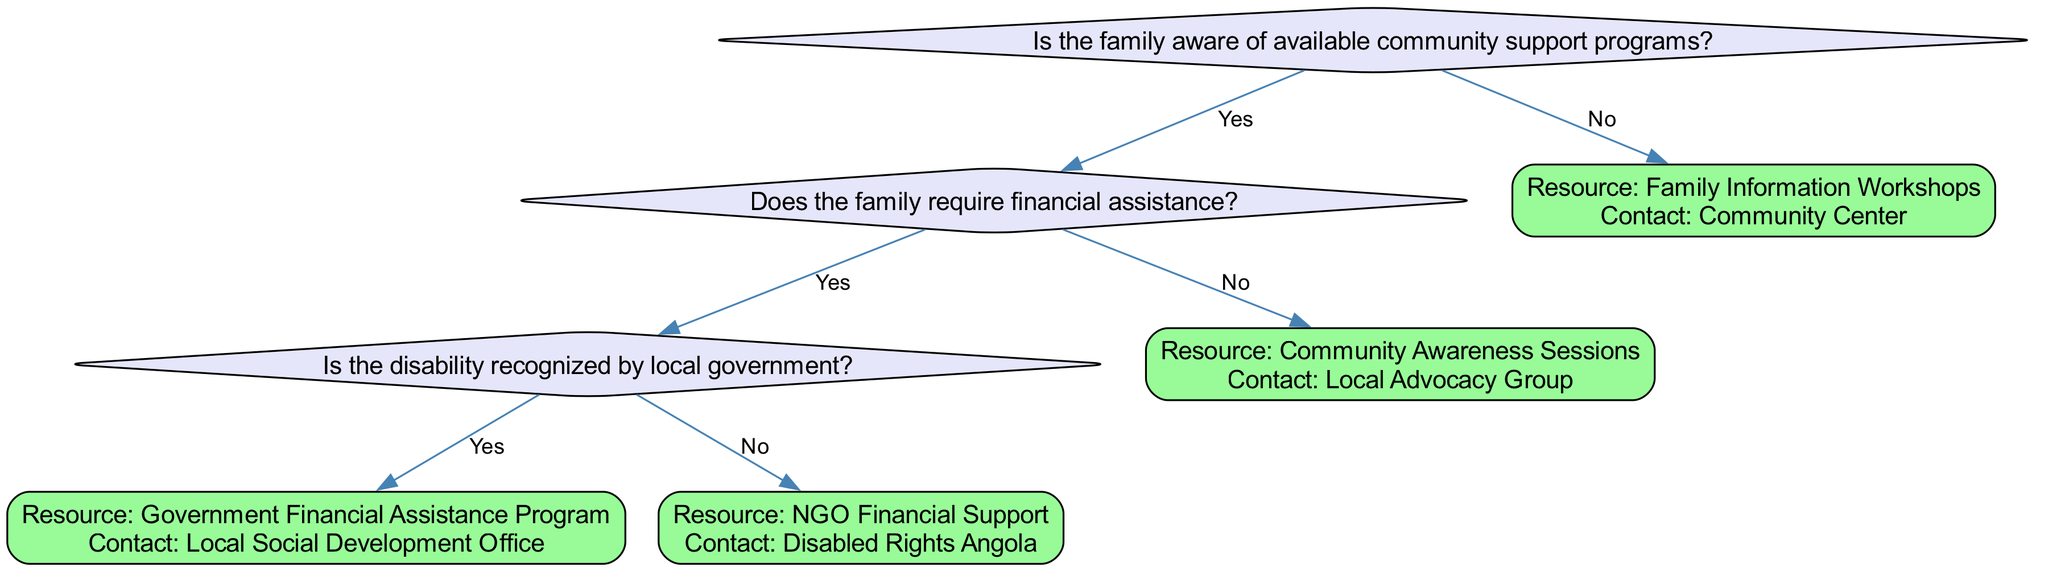Is the first question in the diagram about family awareness of community programs? The diagram begins with a root question which is "Is the family aware of available community support programs?" indicating that this is indeed the first question.
Answer: Yes How many possible paths exist from the root question? The root question has two branches (Yes and No), leading to a total of four distinct outcomes by further branches, thus resulting in four paths: Yes, Yes, Yes; Yes, Yes, No; Yes, No; No.
Answer: Four What resource is provided if the family requires financial assistance and the disability is not recognized by the local government? Following the decision flow, if the family requires financial assistance and the local government does not recognize the disability, the program indicated is "NGO Financial Support."
Answer: NGO Financial Support What contact is associated with community awareness sessions? If the family is aware of community support programs but does not require financial assistance, the resource offered is community awareness sessions, which have "Local Advocacy Group" as the contact.
Answer: Local Advocacy Group What happens if the family is unaware of available community support programs? The decision tree specifies that if the family is unaware, they receive "Family Information Workshops" as a resource, indicating that a response is provided regardless of initial awareness.
Answer: Family Information Workshops What is the last resource listed in the diagram? The diagram's last resource appears at the end of a branch for families who are unaware of any community support, which states "Family Information Workshops." Hence, it's the last resource.
Answer: Family Information Workshops What does the response look like when the family needs financial assistance and the disability is recognized? Under the circumstances where the family needs financial support and the disability is recognized, the response would lead to "Government Financial Assistance Program" per the outlined decision paths.
Answer: Government Financial Assistance Program How many total resources are provided in the diagram? The decision tree provides three distinct resources at the end of various branches: "Government Financial Assistance Program," "NGO Financial Support," and "Family Information Workshops." Thus, the total number of resources is three.
Answer: Three What is the contact for the Government Financial Assistance Program? In the diagram, when the route leads to the Government Financial Assistance Program, the associated contact provided is the "Local Social Development Office."
Answer: Local Social Development Office 